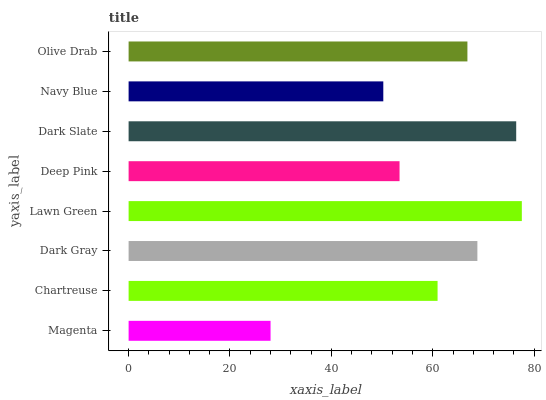Is Magenta the minimum?
Answer yes or no. Yes. Is Lawn Green the maximum?
Answer yes or no. Yes. Is Chartreuse the minimum?
Answer yes or no. No. Is Chartreuse the maximum?
Answer yes or no. No. Is Chartreuse greater than Magenta?
Answer yes or no. Yes. Is Magenta less than Chartreuse?
Answer yes or no. Yes. Is Magenta greater than Chartreuse?
Answer yes or no. No. Is Chartreuse less than Magenta?
Answer yes or no. No. Is Olive Drab the high median?
Answer yes or no. Yes. Is Chartreuse the low median?
Answer yes or no. Yes. Is Chartreuse the high median?
Answer yes or no. No. Is Magenta the low median?
Answer yes or no. No. 